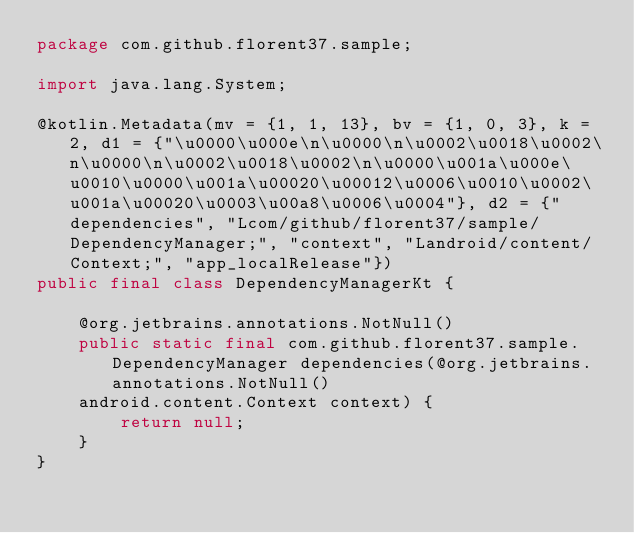Convert code to text. <code><loc_0><loc_0><loc_500><loc_500><_Java_>package com.github.florent37.sample;

import java.lang.System;

@kotlin.Metadata(mv = {1, 1, 13}, bv = {1, 0, 3}, k = 2, d1 = {"\u0000\u000e\n\u0000\n\u0002\u0018\u0002\n\u0000\n\u0002\u0018\u0002\n\u0000\u001a\u000e\u0010\u0000\u001a\u00020\u00012\u0006\u0010\u0002\u001a\u00020\u0003\u00a8\u0006\u0004"}, d2 = {"dependencies", "Lcom/github/florent37/sample/DependencyManager;", "context", "Landroid/content/Context;", "app_localRelease"})
public final class DependencyManagerKt {
    
    @org.jetbrains.annotations.NotNull()
    public static final com.github.florent37.sample.DependencyManager dependencies(@org.jetbrains.annotations.NotNull()
    android.content.Context context) {
        return null;
    }
}</code> 